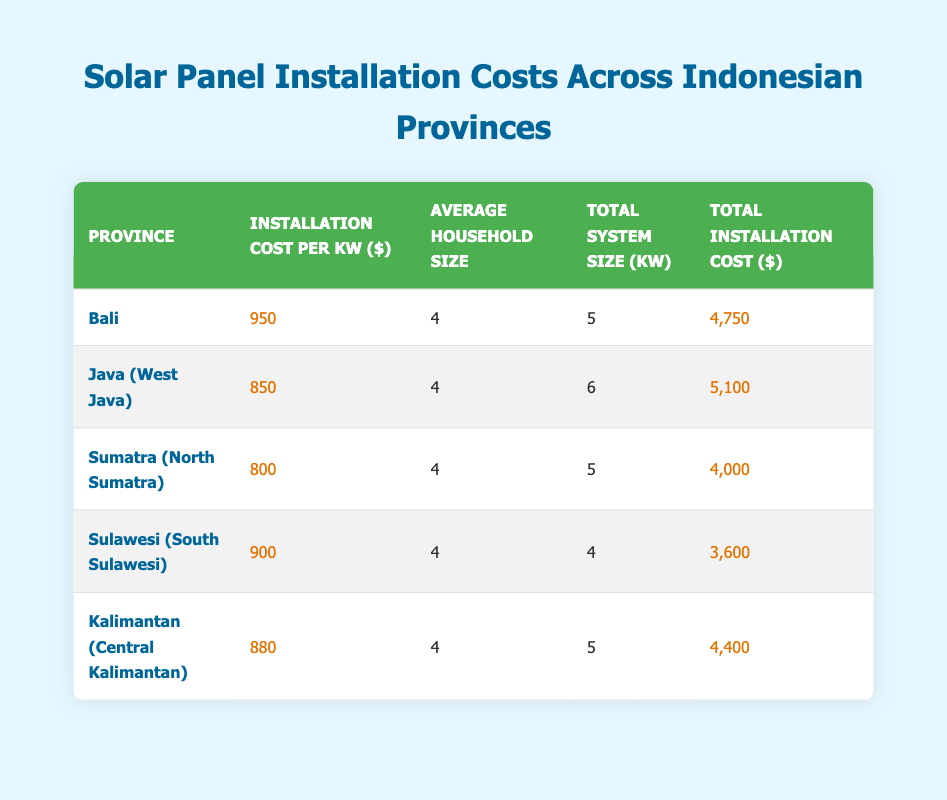What is the installation cost per kW in Sumatra? The table shows that the installation cost per kW in Sumatra (North Sumatra) is listed directly under the respective province. It is 800.
Answer: 800 Which province has the highest total installation cost? To find the highest total installation cost, compare the total installation costs across all provinces. The costs are 4750 for Bali, 5100 for Java (West Java), 4000 for Sumatra (North Sumatra), 3600 for Sulawesi (South Sulawesi), and 4400 for Kalimantan (Central Kalimantan). Java (West Java) has the highest at 5100.
Answer: 5100 What is the average installation cost per kW for all provinces combined? First, sum the installation costs per kW: 950 + 850 + 800 + 900 + 880 = 4380. Then, divide by the number of provinces (5): 4380 / 5 = 876.
Answer: 876 Is the total installation cost in Bali greater than in Kalimantan? The total installation cost in Bali is 4750 and in Kalimantan it is 4400. Since 4750 is greater than 4400, the statement is true.
Answer: Yes What is the difference in total installation costs between Java and Sulawesi? The total installation cost in Java (West Java) is 5100 and in Sulawesi (South Sulawesi) it is 3600. The difference is calculated as 5100 - 3600 = 1500.
Answer: 1500 Which province has the lowest installation cost per kW? Comparing the installation costs per kW across provinces, Sumatra (North Sumatra) has the lowest cost at 800.
Answer: 800 If a household in Sulawesi increased its total system size to 5 kW, what would its total installation cost be? The installation cost per kW in Sulawesi is 900. For a 5 kW system: 5 kW * 900 = 4500.
Answer: 4500 Is the average household size consistent across all provinces? The average household size is consistently listed as 4 for all provinces in the table. Thus, the answer is true.
Answer: Yes What is the total installation cost of all provinces combined? To find the total, we add all the total installation costs: 4750 + 5100 + 4000 + 3600 + 4400 = 21850.
Answer: 21850 